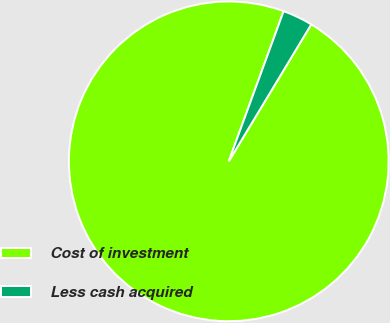Convert chart. <chart><loc_0><loc_0><loc_500><loc_500><pie_chart><fcel>Cost of investment<fcel>Less cash acquired<nl><fcel>96.95%<fcel>3.05%<nl></chart> 